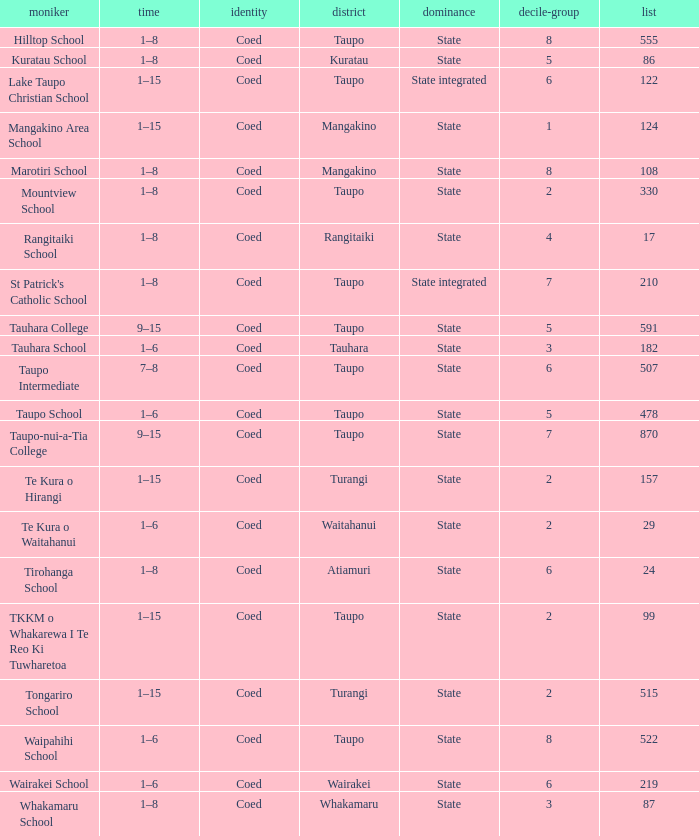Where is the school with state authority that has a roll of more than 157 students? Taupo, Taupo, Taupo, Tauhara, Taupo, Taupo, Taupo, Turangi, Taupo, Wairakei. 